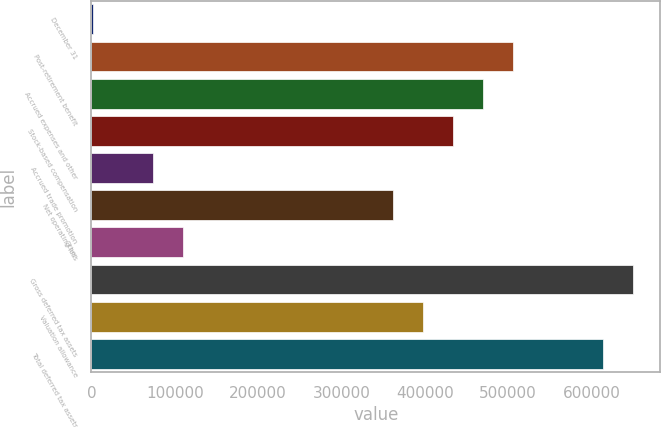Convert chart. <chart><loc_0><loc_0><loc_500><loc_500><bar_chart><fcel>December 31<fcel>Post-retirement benefit<fcel>Accrued expenses and other<fcel>Stock-based compensation<fcel>Accrued trade promotion<fcel>Net operating loss<fcel>Other<fcel>Gross deferred tax assets<fcel>Valuation allowance<fcel>Total deferred tax assets<nl><fcel>2009<fcel>505819<fcel>469832<fcel>433846<fcel>73981.8<fcel>361873<fcel>109968<fcel>649764<fcel>397859<fcel>613778<nl></chart> 